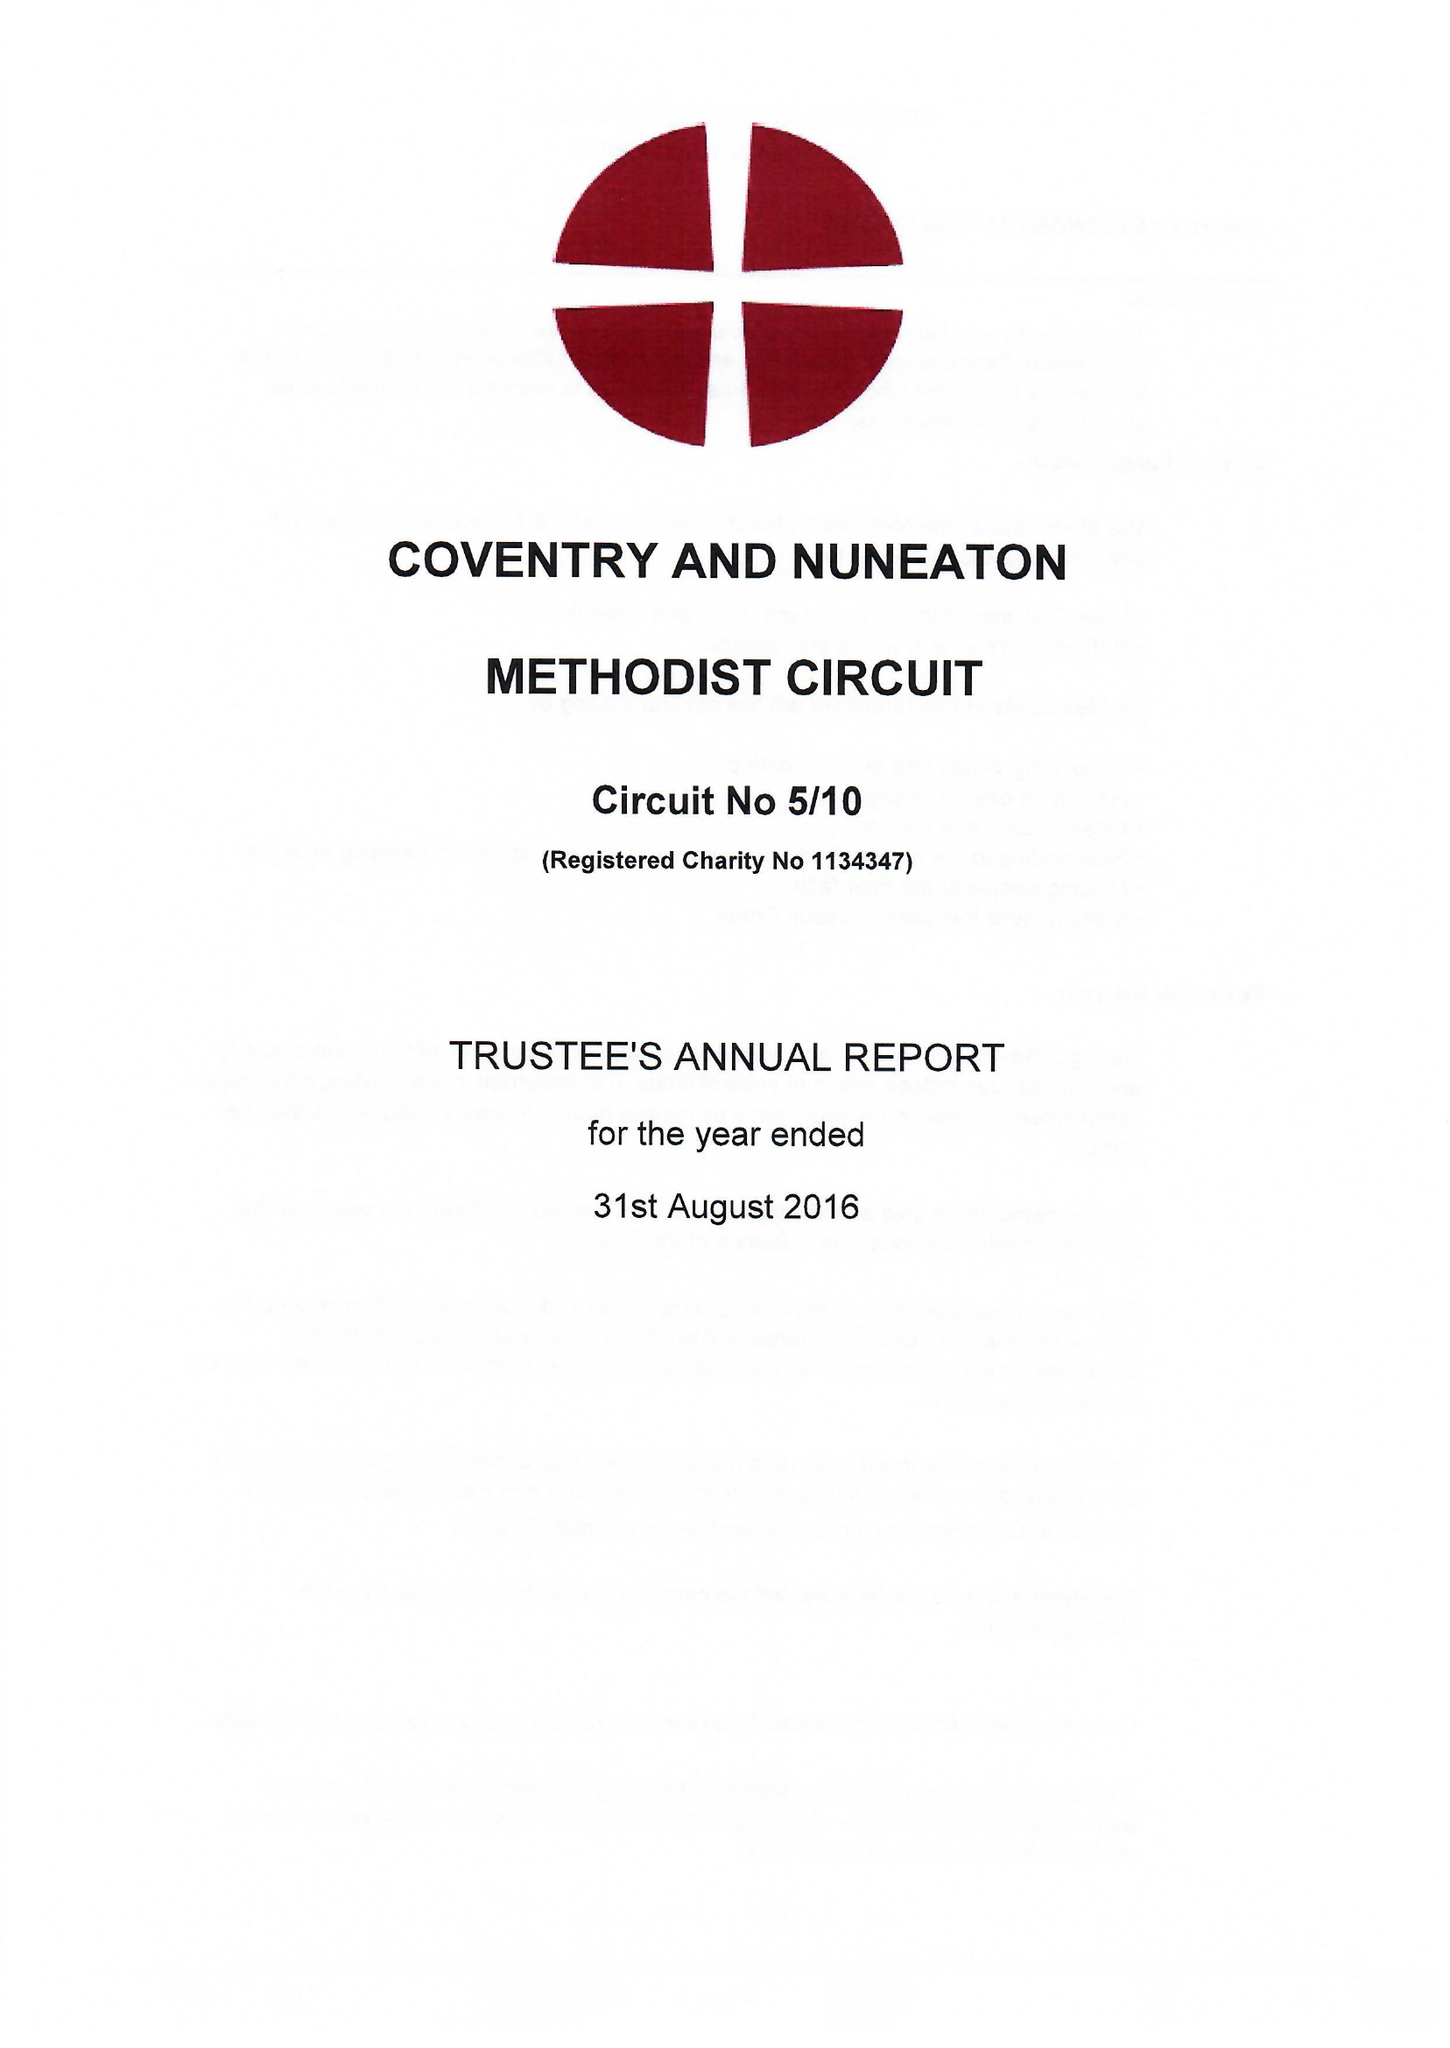What is the value for the address__street_line?
Answer the question using a single word or phrase. WARWICK LANE 